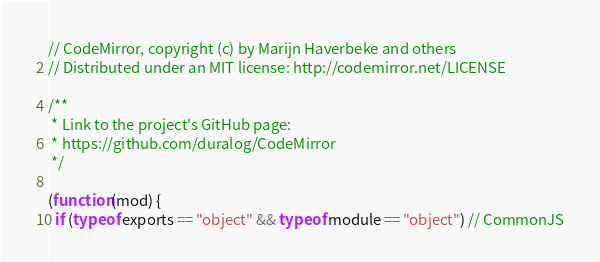Convert code to text. <code><loc_0><loc_0><loc_500><loc_500><_JavaScript_>// CodeMirror, copyright (c) by Marijn Haverbeke and others
// Distributed under an MIT license: http://codemirror.net/LICENSE

/**
 * Link to the project's GitHub page:
 * https://github.com/duralog/CodeMirror
 */

(function(mod) {
  if (typeof exports == "object" && typeof module == "object") // CommonJS</code> 